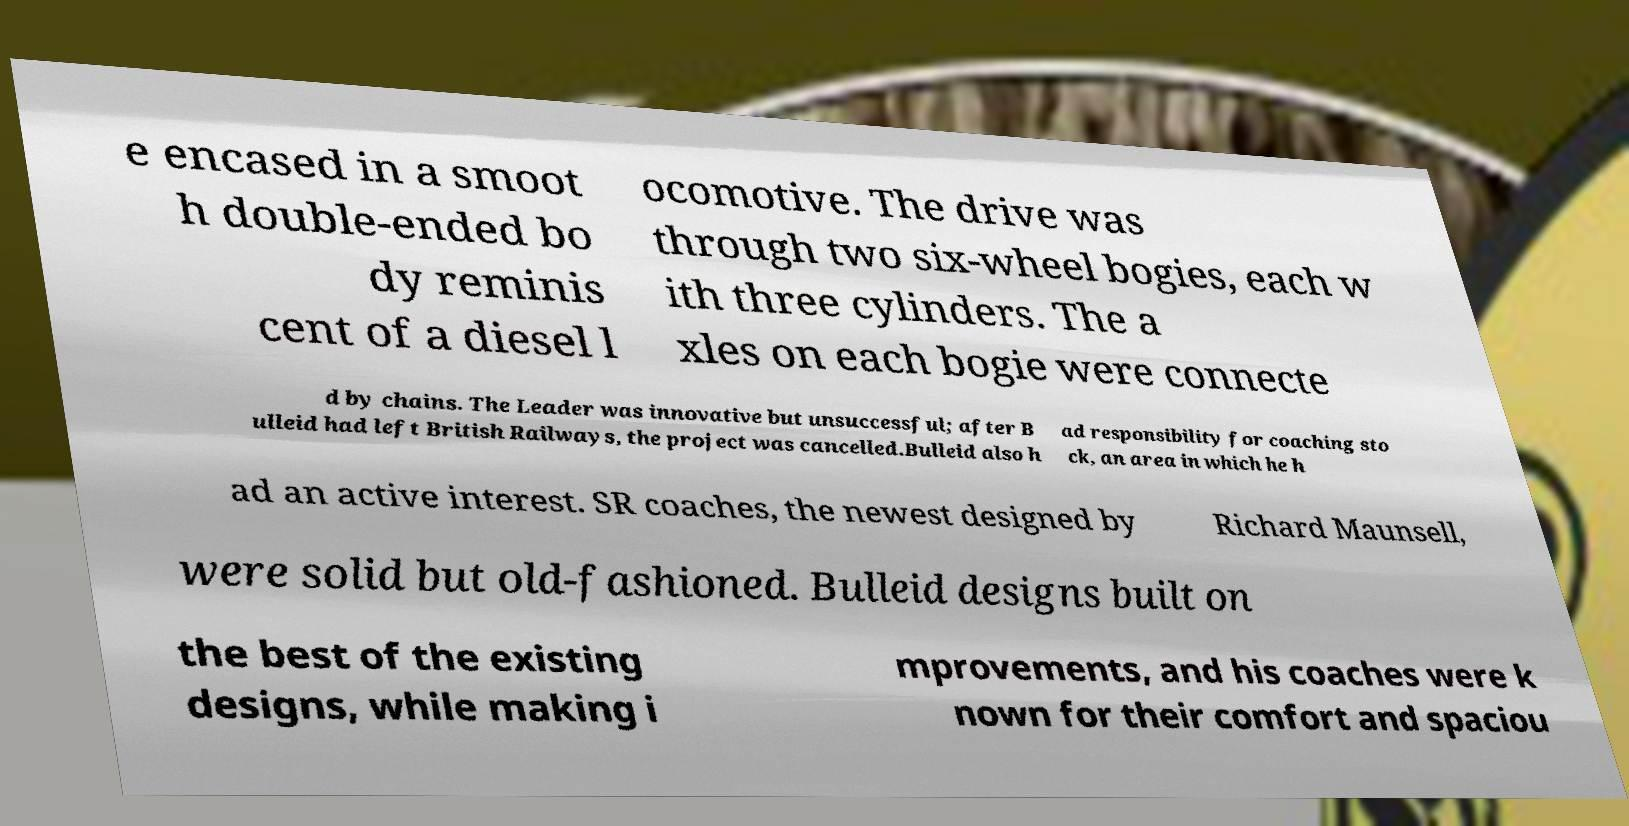Can you accurately transcribe the text from the provided image for me? e encased in a smoot h double-ended bo dy reminis cent of a diesel l ocomotive. The drive was through two six-wheel bogies, each w ith three cylinders. The a xles on each bogie were connecte d by chains. The Leader was innovative but unsuccessful; after B ulleid had left British Railways, the project was cancelled.Bulleid also h ad responsibility for coaching sto ck, an area in which he h ad an active interest. SR coaches, the newest designed by Richard Maunsell, were solid but old-fashioned. Bulleid designs built on the best of the existing designs, while making i mprovements, and his coaches were k nown for their comfort and spaciou 